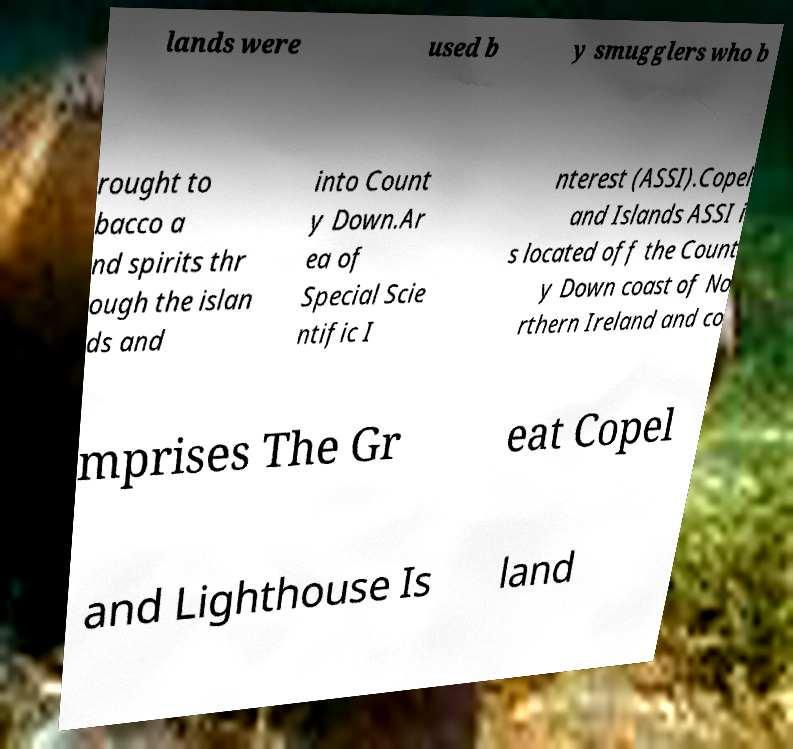Can you read and provide the text displayed in the image?This photo seems to have some interesting text. Can you extract and type it out for me? lands were used b y smugglers who b rought to bacco a nd spirits thr ough the islan ds and into Count y Down.Ar ea of Special Scie ntific I nterest (ASSI).Copel and Islands ASSI i s located off the Count y Down coast of No rthern Ireland and co mprises The Gr eat Copel and Lighthouse Is land 